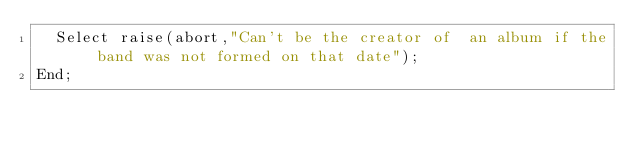Convert code to text. <code><loc_0><loc_0><loc_500><loc_500><_SQL_>  Select raise(abort,"Can't be the creator of  an album if the band was not formed on that date");
End;</code> 